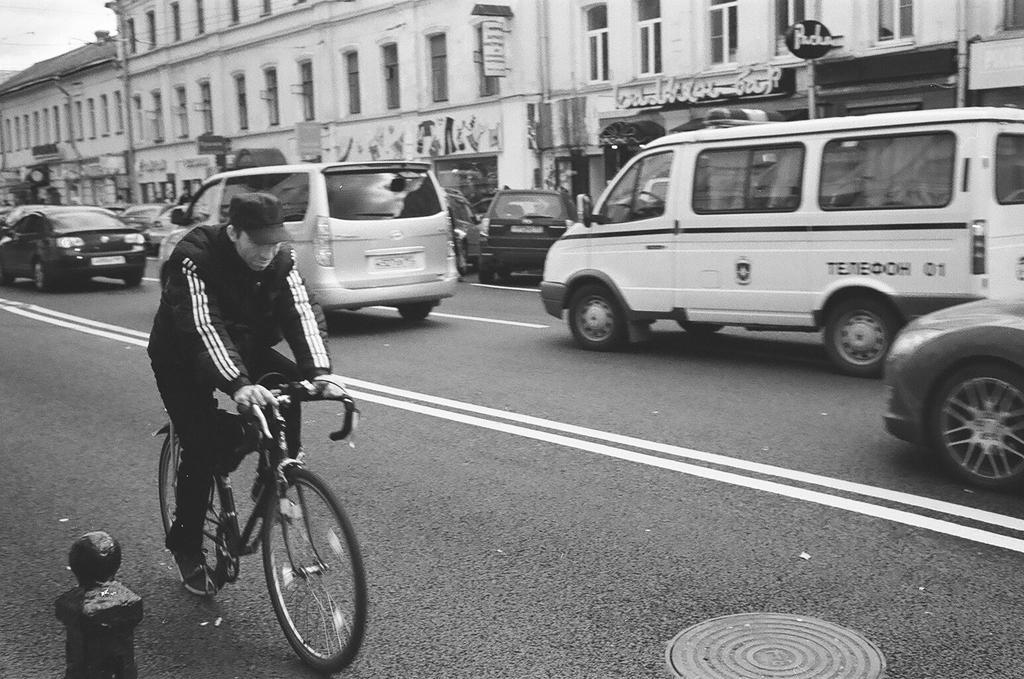How would you summarize this image in a sentence or two? In this image there are vehicles which are passing through the road and at the middle of the image there is a person wearing black color jacket riding bicycle and at the background of the image there is a building 